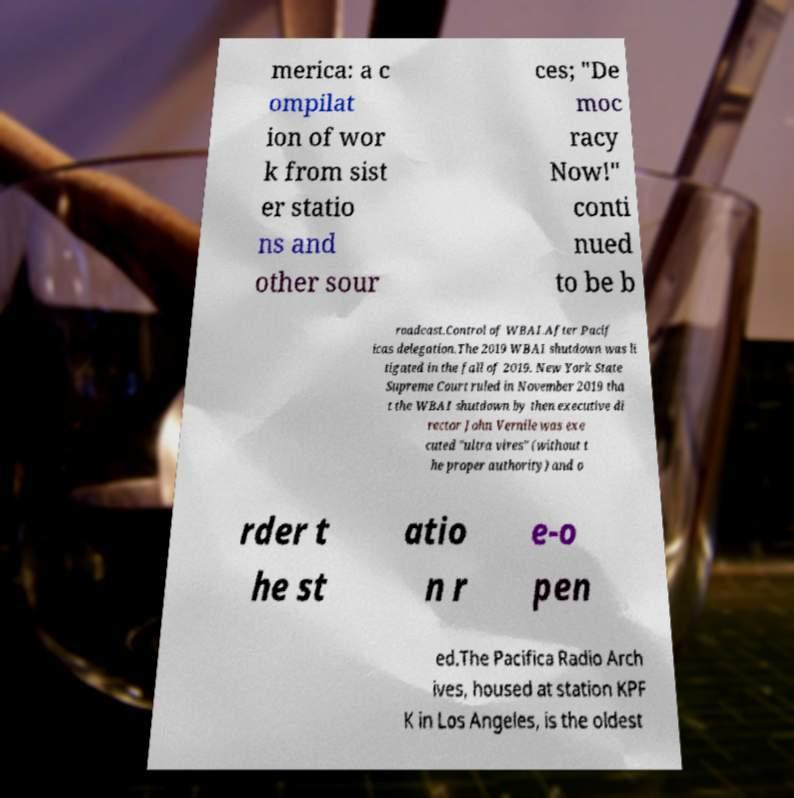I need the written content from this picture converted into text. Can you do that? merica: a c ompilat ion of wor k from sist er statio ns and other sour ces; "De moc racy Now!" conti nued to be b roadcast.Control of WBAI.After Pacif icas delegation.The 2019 WBAI shutdown was li tigated in the fall of 2019. New York State Supreme Court ruled in November 2019 tha t the WBAI shutdown by then executive di rector John Vernile was exe cuted "ultra vires" (without t he proper authority) and o rder t he st atio n r e-o pen ed.The Pacifica Radio Arch ives, housed at station KPF K in Los Angeles, is the oldest 